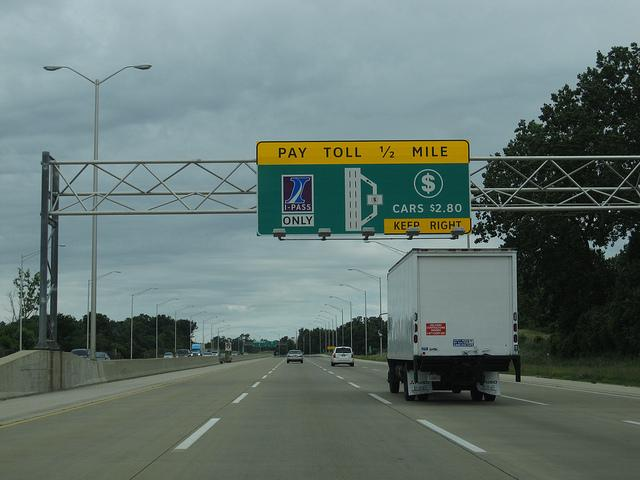What company handles the event that will happen in 1/2 mile? ez pass 